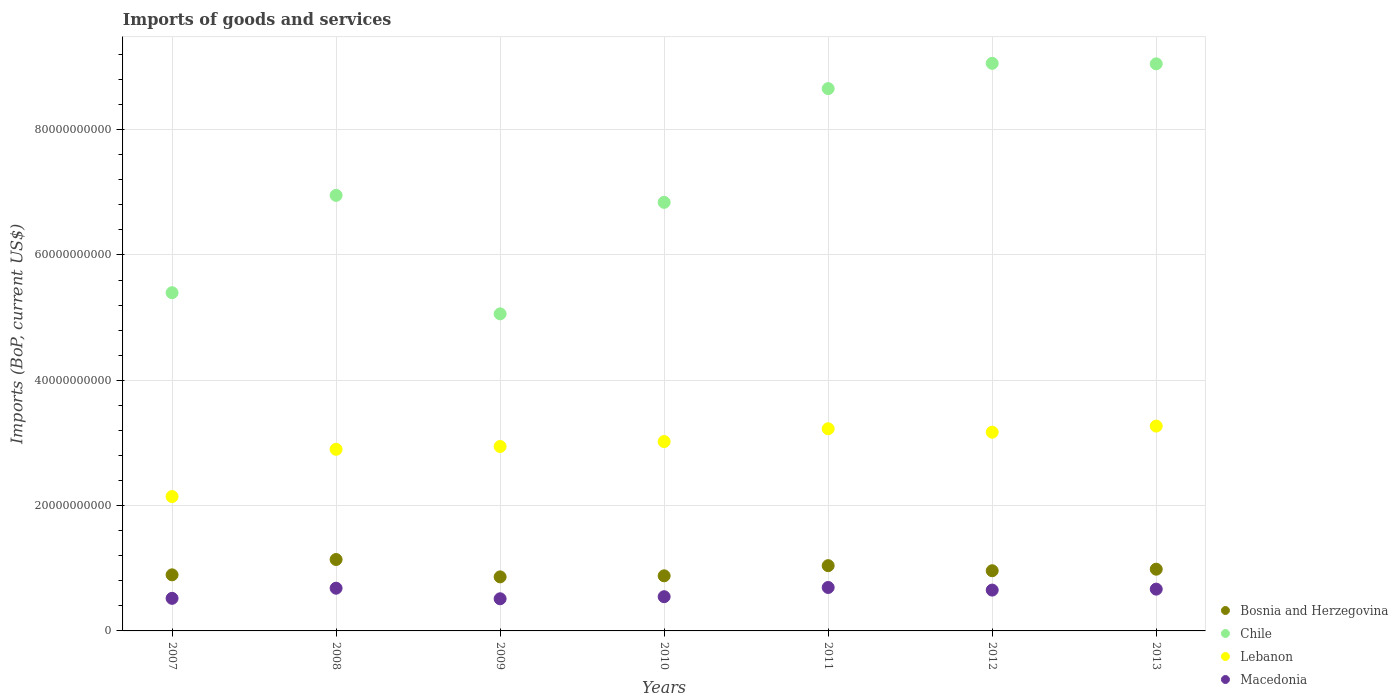What is the amount spent on imports in Chile in 2012?
Your response must be concise. 9.06e+1. Across all years, what is the maximum amount spent on imports in Bosnia and Herzegovina?
Offer a very short reply. 1.14e+1. Across all years, what is the minimum amount spent on imports in Lebanon?
Make the answer very short. 2.14e+1. What is the total amount spent on imports in Bosnia and Herzegovina in the graph?
Offer a terse response. 6.76e+1. What is the difference between the amount spent on imports in Chile in 2011 and that in 2012?
Ensure brevity in your answer.  -4.03e+09. What is the difference between the amount spent on imports in Bosnia and Herzegovina in 2013 and the amount spent on imports in Macedonia in 2008?
Offer a very short reply. 3.03e+09. What is the average amount spent on imports in Chile per year?
Give a very brief answer. 7.29e+1. In the year 2010, what is the difference between the amount spent on imports in Chile and amount spent on imports in Bosnia and Herzegovina?
Make the answer very short. 5.96e+1. What is the ratio of the amount spent on imports in Macedonia in 2007 to that in 2012?
Your response must be concise. 0.8. Is the amount spent on imports in Bosnia and Herzegovina in 2008 less than that in 2013?
Provide a short and direct response. No. Is the difference between the amount spent on imports in Chile in 2008 and 2010 greater than the difference between the amount spent on imports in Bosnia and Herzegovina in 2008 and 2010?
Your answer should be very brief. No. What is the difference between the highest and the second highest amount spent on imports in Chile?
Your response must be concise. 7.72e+07. What is the difference between the highest and the lowest amount spent on imports in Bosnia and Herzegovina?
Your answer should be compact. 2.77e+09. Does the amount spent on imports in Bosnia and Herzegovina monotonically increase over the years?
Offer a very short reply. No. How many dotlines are there?
Provide a succinct answer. 4. How many years are there in the graph?
Offer a very short reply. 7. Are the values on the major ticks of Y-axis written in scientific E-notation?
Give a very brief answer. No. Does the graph contain grids?
Provide a short and direct response. Yes. What is the title of the graph?
Offer a terse response. Imports of goods and services. Does "Guam" appear as one of the legend labels in the graph?
Your answer should be compact. No. What is the label or title of the Y-axis?
Offer a very short reply. Imports (BoP, current US$). What is the Imports (BoP, current US$) in Bosnia and Herzegovina in 2007?
Your answer should be compact. 8.95e+09. What is the Imports (BoP, current US$) in Chile in 2007?
Your response must be concise. 5.40e+1. What is the Imports (BoP, current US$) in Lebanon in 2007?
Make the answer very short. 2.14e+1. What is the Imports (BoP, current US$) of Macedonia in 2007?
Ensure brevity in your answer.  5.20e+09. What is the Imports (BoP, current US$) in Bosnia and Herzegovina in 2008?
Offer a very short reply. 1.14e+1. What is the Imports (BoP, current US$) in Chile in 2008?
Make the answer very short. 6.95e+1. What is the Imports (BoP, current US$) in Lebanon in 2008?
Provide a short and direct response. 2.90e+1. What is the Imports (BoP, current US$) of Macedonia in 2008?
Give a very brief answer. 6.82e+09. What is the Imports (BoP, current US$) of Bosnia and Herzegovina in 2009?
Offer a terse response. 8.62e+09. What is the Imports (BoP, current US$) in Chile in 2009?
Provide a succinct answer. 5.06e+1. What is the Imports (BoP, current US$) of Lebanon in 2009?
Your answer should be compact. 2.94e+1. What is the Imports (BoP, current US$) in Macedonia in 2009?
Make the answer very short. 5.13e+09. What is the Imports (BoP, current US$) in Bosnia and Herzegovina in 2010?
Provide a succinct answer. 8.79e+09. What is the Imports (BoP, current US$) in Chile in 2010?
Your answer should be very brief. 6.84e+1. What is the Imports (BoP, current US$) of Lebanon in 2010?
Offer a terse response. 3.02e+1. What is the Imports (BoP, current US$) of Macedonia in 2010?
Provide a succinct answer. 5.46e+09. What is the Imports (BoP, current US$) in Bosnia and Herzegovina in 2011?
Offer a very short reply. 1.04e+1. What is the Imports (BoP, current US$) in Chile in 2011?
Offer a very short reply. 8.66e+1. What is the Imports (BoP, current US$) of Lebanon in 2011?
Your answer should be compact. 3.23e+1. What is the Imports (BoP, current US$) of Macedonia in 2011?
Provide a succinct answer. 6.93e+09. What is the Imports (BoP, current US$) of Bosnia and Herzegovina in 2012?
Make the answer very short. 9.60e+09. What is the Imports (BoP, current US$) in Chile in 2012?
Your response must be concise. 9.06e+1. What is the Imports (BoP, current US$) of Lebanon in 2012?
Your answer should be very brief. 3.17e+1. What is the Imports (BoP, current US$) in Macedonia in 2012?
Provide a short and direct response. 6.52e+09. What is the Imports (BoP, current US$) in Bosnia and Herzegovina in 2013?
Your response must be concise. 9.85e+09. What is the Imports (BoP, current US$) of Chile in 2013?
Your answer should be very brief. 9.05e+1. What is the Imports (BoP, current US$) in Lebanon in 2013?
Make the answer very short. 3.27e+1. What is the Imports (BoP, current US$) in Macedonia in 2013?
Make the answer very short. 6.67e+09. Across all years, what is the maximum Imports (BoP, current US$) in Bosnia and Herzegovina?
Provide a succinct answer. 1.14e+1. Across all years, what is the maximum Imports (BoP, current US$) of Chile?
Make the answer very short. 9.06e+1. Across all years, what is the maximum Imports (BoP, current US$) of Lebanon?
Offer a terse response. 3.27e+1. Across all years, what is the maximum Imports (BoP, current US$) of Macedonia?
Offer a terse response. 6.93e+09. Across all years, what is the minimum Imports (BoP, current US$) of Bosnia and Herzegovina?
Ensure brevity in your answer.  8.62e+09. Across all years, what is the minimum Imports (BoP, current US$) of Chile?
Provide a succinct answer. 5.06e+1. Across all years, what is the minimum Imports (BoP, current US$) of Lebanon?
Make the answer very short. 2.14e+1. Across all years, what is the minimum Imports (BoP, current US$) of Macedonia?
Ensure brevity in your answer.  5.13e+09. What is the total Imports (BoP, current US$) in Bosnia and Herzegovina in the graph?
Your response must be concise. 6.76e+1. What is the total Imports (BoP, current US$) of Chile in the graph?
Ensure brevity in your answer.  5.10e+11. What is the total Imports (BoP, current US$) in Lebanon in the graph?
Offer a very short reply. 2.07e+11. What is the total Imports (BoP, current US$) in Macedonia in the graph?
Offer a terse response. 4.27e+1. What is the difference between the Imports (BoP, current US$) in Bosnia and Herzegovina in 2007 and that in 2008?
Ensure brevity in your answer.  -2.45e+09. What is the difference between the Imports (BoP, current US$) of Chile in 2007 and that in 2008?
Your answer should be compact. -1.55e+1. What is the difference between the Imports (BoP, current US$) of Lebanon in 2007 and that in 2008?
Keep it short and to the point. -7.54e+09. What is the difference between the Imports (BoP, current US$) in Macedonia in 2007 and that in 2008?
Your answer should be compact. -1.62e+09. What is the difference between the Imports (BoP, current US$) in Bosnia and Herzegovina in 2007 and that in 2009?
Offer a terse response. 3.25e+08. What is the difference between the Imports (BoP, current US$) of Chile in 2007 and that in 2009?
Your answer should be compact. 3.37e+09. What is the difference between the Imports (BoP, current US$) in Lebanon in 2007 and that in 2009?
Give a very brief answer. -7.99e+09. What is the difference between the Imports (BoP, current US$) of Macedonia in 2007 and that in 2009?
Offer a very short reply. 6.79e+07. What is the difference between the Imports (BoP, current US$) in Bosnia and Herzegovina in 2007 and that in 2010?
Your response must be concise. 1.56e+08. What is the difference between the Imports (BoP, current US$) of Chile in 2007 and that in 2010?
Provide a short and direct response. -1.44e+1. What is the difference between the Imports (BoP, current US$) of Lebanon in 2007 and that in 2010?
Your answer should be compact. -8.78e+09. What is the difference between the Imports (BoP, current US$) of Macedonia in 2007 and that in 2010?
Offer a very short reply. -2.63e+08. What is the difference between the Imports (BoP, current US$) in Bosnia and Herzegovina in 2007 and that in 2011?
Offer a very short reply. -1.47e+09. What is the difference between the Imports (BoP, current US$) in Chile in 2007 and that in 2011?
Offer a very short reply. -3.26e+1. What is the difference between the Imports (BoP, current US$) in Lebanon in 2007 and that in 2011?
Your answer should be very brief. -1.08e+1. What is the difference between the Imports (BoP, current US$) in Macedonia in 2007 and that in 2011?
Your response must be concise. -1.73e+09. What is the difference between the Imports (BoP, current US$) in Bosnia and Herzegovina in 2007 and that in 2012?
Offer a terse response. -6.55e+08. What is the difference between the Imports (BoP, current US$) in Chile in 2007 and that in 2012?
Give a very brief answer. -3.66e+1. What is the difference between the Imports (BoP, current US$) of Lebanon in 2007 and that in 2012?
Provide a short and direct response. -1.03e+1. What is the difference between the Imports (BoP, current US$) of Macedonia in 2007 and that in 2012?
Give a very brief answer. -1.32e+09. What is the difference between the Imports (BoP, current US$) in Bosnia and Herzegovina in 2007 and that in 2013?
Your answer should be compact. -9.02e+08. What is the difference between the Imports (BoP, current US$) in Chile in 2007 and that in 2013?
Provide a short and direct response. -3.65e+1. What is the difference between the Imports (BoP, current US$) in Lebanon in 2007 and that in 2013?
Your answer should be very brief. -1.12e+1. What is the difference between the Imports (BoP, current US$) of Macedonia in 2007 and that in 2013?
Offer a very short reply. -1.47e+09. What is the difference between the Imports (BoP, current US$) of Bosnia and Herzegovina in 2008 and that in 2009?
Provide a short and direct response. 2.77e+09. What is the difference between the Imports (BoP, current US$) of Chile in 2008 and that in 2009?
Your answer should be compact. 1.89e+1. What is the difference between the Imports (BoP, current US$) in Lebanon in 2008 and that in 2009?
Make the answer very short. -4.48e+08. What is the difference between the Imports (BoP, current US$) of Macedonia in 2008 and that in 2009?
Offer a terse response. 1.69e+09. What is the difference between the Imports (BoP, current US$) in Bosnia and Herzegovina in 2008 and that in 2010?
Offer a terse response. 2.60e+09. What is the difference between the Imports (BoP, current US$) in Chile in 2008 and that in 2010?
Give a very brief answer. 1.12e+09. What is the difference between the Imports (BoP, current US$) of Lebanon in 2008 and that in 2010?
Offer a very short reply. -1.23e+09. What is the difference between the Imports (BoP, current US$) of Macedonia in 2008 and that in 2010?
Give a very brief answer. 1.36e+09. What is the difference between the Imports (BoP, current US$) in Bosnia and Herzegovina in 2008 and that in 2011?
Offer a very short reply. 9.82e+08. What is the difference between the Imports (BoP, current US$) in Chile in 2008 and that in 2011?
Provide a succinct answer. -1.70e+1. What is the difference between the Imports (BoP, current US$) in Lebanon in 2008 and that in 2011?
Keep it short and to the point. -3.28e+09. What is the difference between the Imports (BoP, current US$) of Macedonia in 2008 and that in 2011?
Your answer should be compact. -1.15e+08. What is the difference between the Imports (BoP, current US$) of Bosnia and Herzegovina in 2008 and that in 2012?
Ensure brevity in your answer.  1.79e+09. What is the difference between the Imports (BoP, current US$) of Chile in 2008 and that in 2012?
Your response must be concise. -2.11e+1. What is the difference between the Imports (BoP, current US$) of Lebanon in 2008 and that in 2012?
Your response must be concise. -2.73e+09. What is the difference between the Imports (BoP, current US$) in Macedonia in 2008 and that in 2012?
Offer a terse response. 3.02e+08. What is the difference between the Imports (BoP, current US$) in Bosnia and Herzegovina in 2008 and that in 2013?
Provide a succinct answer. 1.55e+09. What is the difference between the Imports (BoP, current US$) of Chile in 2008 and that in 2013?
Provide a succinct answer. -2.10e+1. What is the difference between the Imports (BoP, current US$) in Lebanon in 2008 and that in 2013?
Provide a succinct answer. -3.70e+09. What is the difference between the Imports (BoP, current US$) of Macedonia in 2008 and that in 2013?
Your answer should be compact. 1.50e+08. What is the difference between the Imports (BoP, current US$) of Bosnia and Herzegovina in 2009 and that in 2010?
Offer a very short reply. -1.69e+08. What is the difference between the Imports (BoP, current US$) in Chile in 2009 and that in 2010?
Your answer should be compact. -1.78e+1. What is the difference between the Imports (BoP, current US$) in Lebanon in 2009 and that in 2010?
Give a very brief answer. -7.85e+08. What is the difference between the Imports (BoP, current US$) of Macedonia in 2009 and that in 2010?
Give a very brief answer. -3.31e+08. What is the difference between the Imports (BoP, current US$) in Bosnia and Herzegovina in 2009 and that in 2011?
Offer a very short reply. -1.79e+09. What is the difference between the Imports (BoP, current US$) of Chile in 2009 and that in 2011?
Provide a succinct answer. -3.60e+1. What is the difference between the Imports (BoP, current US$) in Lebanon in 2009 and that in 2011?
Give a very brief answer. -2.83e+09. What is the difference between the Imports (BoP, current US$) in Macedonia in 2009 and that in 2011?
Your response must be concise. -1.80e+09. What is the difference between the Imports (BoP, current US$) of Bosnia and Herzegovina in 2009 and that in 2012?
Ensure brevity in your answer.  -9.80e+08. What is the difference between the Imports (BoP, current US$) of Chile in 2009 and that in 2012?
Give a very brief answer. -4.00e+1. What is the difference between the Imports (BoP, current US$) in Lebanon in 2009 and that in 2012?
Offer a very short reply. -2.28e+09. What is the difference between the Imports (BoP, current US$) in Macedonia in 2009 and that in 2012?
Give a very brief answer. -1.39e+09. What is the difference between the Imports (BoP, current US$) of Bosnia and Herzegovina in 2009 and that in 2013?
Your response must be concise. -1.23e+09. What is the difference between the Imports (BoP, current US$) in Chile in 2009 and that in 2013?
Make the answer very short. -3.99e+1. What is the difference between the Imports (BoP, current US$) of Lebanon in 2009 and that in 2013?
Provide a short and direct response. -3.26e+09. What is the difference between the Imports (BoP, current US$) in Macedonia in 2009 and that in 2013?
Provide a succinct answer. -1.54e+09. What is the difference between the Imports (BoP, current US$) in Bosnia and Herzegovina in 2010 and that in 2011?
Ensure brevity in your answer.  -1.62e+09. What is the difference between the Imports (BoP, current US$) of Chile in 2010 and that in 2011?
Ensure brevity in your answer.  -1.82e+1. What is the difference between the Imports (BoP, current US$) in Lebanon in 2010 and that in 2011?
Provide a succinct answer. -2.05e+09. What is the difference between the Imports (BoP, current US$) in Macedonia in 2010 and that in 2011?
Provide a succinct answer. -1.47e+09. What is the difference between the Imports (BoP, current US$) in Bosnia and Herzegovina in 2010 and that in 2012?
Your response must be concise. -8.11e+08. What is the difference between the Imports (BoP, current US$) of Chile in 2010 and that in 2012?
Ensure brevity in your answer.  -2.22e+1. What is the difference between the Imports (BoP, current US$) in Lebanon in 2010 and that in 2012?
Your response must be concise. -1.50e+09. What is the difference between the Imports (BoP, current US$) of Macedonia in 2010 and that in 2012?
Your answer should be very brief. -1.05e+09. What is the difference between the Imports (BoP, current US$) in Bosnia and Herzegovina in 2010 and that in 2013?
Your answer should be compact. -1.06e+09. What is the difference between the Imports (BoP, current US$) in Chile in 2010 and that in 2013?
Provide a short and direct response. -2.21e+1. What is the difference between the Imports (BoP, current US$) of Lebanon in 2010 and that in 2013?
Make the answer very short. -2.47e+09. What is the difference between the Imports (BoP, current US$) in Macedonia in 2010 and that in 2013?
Your response must be concise. -1.21e+09. What is the difference between the Imports (BoP, current US$) of Bosnia and Herzegovina in 2011 and that in 2012?
Your answer should be very brief. 8.11e+08. What is the difference between the Imports (BoP, current US$) of Chile in 2011 and that in 2012?
Provide a succinct answer. -4.03e+09. What is the difference between the Imports (BoP, current US$) in Lebanon in 2011 and that in 2012?
Your response must be concise. 5.51e+08. What is the difference between the Imports (BoP, current US$) in Macedonia in 2011 and that in 2012?
Your response must be concise. 4.17e+08. What is the difference between the Imports (BoP, current US$) of Bosnia and Herzegovina in 2011 and that in 2013?
Your answer should be compact. 5.64e+08. What is the difference between the Imports (BoP, current US$) in Chile in 2011 and that in 2013?
Your answer should be very brief. -3.95e+09. What is the difference between the Imports (BoP, current US$) of Lebanon in 2011 and that in 2013?
Give a very brief answer. -4.26e+08. What is the difference between the Imports (BoP, current US$) in Macedonia in 2011 and that in 2013?
Give a very brief answer. 2.65e+08. What is the difference between the Imports (BoP, current US$) of Bosnia and Herzegovina in 2012 and that in 2013?
Provide a succinct answer. -2.47e+08. What is the difference between the Imports (BoP, current US$) of Chile in 2012 and that in 2013?
Keep it short and to the point. 7.72e+07. What is the difference between the Imports (BoP, current US$) of Lebanon in 2012 and that in 2013?
Give a very brief answer. -9.77e+08. What is the difference between the Imports (BoP, current US$) of Macedonia in 2012 and that in 2013?
Provide a short and direct response. -1.52e+08. What is the difference between the Imports (BoP, current US$) in Bosnia and Herzegovina in 2007 and the Imports (BoP, current US$) in Chile in 2008?
Provide a short and direct response. -6.06e+1. What is the difference between the Imports (BoP, current US$) of Bosnia and Herzegovina in 2007 and the Imports (BoP, current US$) of Lebanon in 2008?
Provide a succinct answer. -2.00e+1. What is the difference between the Imports (BoP, current US$) of Bosnia and Herzegovina in 2007 and the Imports (BoP, current US$) of Macedonia in 2008?
Keep it short and to the point. 2.13e+09. What is the difference between the Imports (BoP, current US$) in Chile in 2007 and the Imports (BoP, current US$) in Lebanon in 2008?
Ensure brevity in your answer.  2.50e+1. What is the difference between the Imports (BoP, current US$) of Chile in 2007 and the Imports (BoP, current US$) of Macedonia in 2008?
Provide a short and direct response. 4.72e+1. What is the difference between the Imports (BoP, current US$) of Lebanon in 2007 and the Imports (BoP, current US$) of Macedonia in 2008?
Give a very brief answer. 1.46e+1. What is the difference between the Imports (BoP, current US$) of Bosnia and Herzegovina in 2007 and the Imports (BoP, current US$) of Chile in 2009?
Provide a short and direct response. -4.17e+1. What is the difference between the Imports (BoP, current US$) in Bosnia and Herzegovina in 2007 and the Imports (BoP, current US$) in Lebanon in 2009?
Keep it short and to the point. -2.05e+1. What is the difference between the Imports (BoP, current US$) of Bosnia and Herzegovina in 2007 and the Imports (BoP, current US$) of Macedonia in 2009?
Give a very brief answer. 3.82e+09. What is the difference between the Imports (BoP, current US$) of Chile in 2007 and the Imports (BoP, current US$) of Lebanon in 2009?
Provide a succinct answer. 2.45e+1. What is the difference between the Imports (BoP, current US$) of Chile in 2007 and the Imports (BoP, current US$) of Macedonia in 2009?
Provide a succinct answer. 4.88e+1. What is the difference between the Imports (BoP, current US$) in Lebanon in 2007 and the Imports (BoP, current US$) in Macedonia in 2009?
Your answer should be compact. 1.63e+1. What is the difference between the Imports (BoP, current US$) of Bosnia and Herzegovina in 2007 and the Imports (BoP, current US$) of Chile in 2010?
Your answer should be compact. -5.95e+1. What is the difference between the Imports (BoP, current US$) of Bosnia and Herzegovina in 2007 and the Imports (BoP, current US$) of Lebanon in 2010?
Make the answer very short. -2.13e+1. What is the difference between the Imports (BoP, current US$) of Bosnia and Herzegovina in 2007 and the Imports (BoP, current US$) of Macedonia in 2010?
Make the answer very short. 3.49e+09. What is the difference between the Imports (BoP, current US$) in Chile in 2007 and the Imports (BoP, current US$) in Lebanon in 2010?
Your response must be concise. 2.38e+1. What is the difference between the Imports (BoP, current US$) of Chile in 2007 and the Imports (BoP, current US$) of Macedonia in 2010?
Your answer should be very brief. 4.85e+1. What is the difference between the Imports (BoP, current US$) in Lebanon in 2007 and the Imports (BoP, current US$) in Macedonia in 2010?
Provide a succinct answer. 1.60e+1. What is the difference between the Imports (BoP, current US$) in Bosnia and Herzegovina in 2007 and the Imports (BoP, current US$) in Chile in 2011?
Keep it short and to the point. -7.76e+1. What is the difference between the Imports (BoP, current US$) in Bosnia and Herzegovina in 2007 and the Imports (BoP, current US$) in Lebanon in 2011?
Ensure brevity in your answer.  -2.33e+1. What is the difference between the Imports (BoP, current US$) in Bosnia and Herzegovina in 2007 and the Imports (BoP, current US$) in Macedonia in 2011?
Offer a terse response. 2.02e+09. What is the difference between the Imports (BoP, current US$) in Chile in 2007 and the Imports (BoP, current US$) in Lebanon in 2011?
Offer a terse response. 2.17e+1. What is the difference between the Imports (BoP, current US$) in Chile in 2007 and the Imports (BoP, current US$) in Macedonia in 2011?
Your answer should be compact. 4.70e+1. What is the difference between the Imports (BoP, current US$) of Lebanon in 2007 and the Imports (BoP, current US$) of Macedonia in 2011?
Offer a terse response. 1.45e+1. What is the difference between the Imports (BoP, current US$) of Bosnia and Herzegovina in 2007 and the Imports (BoP, current US$) of Chile in 2012?
Make the answer very short. -8.16e+1. What is the difference between the Imports (BoP, current US$) in Bosnia and Herzegovina in 2007 and the Imports (BoP, current US$) in Lebanon in 2012?
Your response must be concise. -2.28e+1. What is the difference between the Imports (BoP, current US$) of Bosnia and Herzegovina in 2007 and the Imports (BoP, current US$) of Macedonia in 2012?
Your answer should be compact. 2.43e+09. What is the difference between the Imports (BoP, current US$) in Chile in 2007 and the Imports (BoP, current US$) in Lebanon in 2012?
Provide a short and direct response. 2.23e+1. What is the difference between the Imports (BoP, current US$) in Chile in 2007 and the Imports (BoP, current US$) in Macedonia in 2012?
Offer a very short reply. 4.75e+1. What is the difference between the Imports (BoP, current US$) of Lebanon in 2007 and the Imports (BoP, current US$) of Macedonia in 2012?
Provide a short and direct response. 1.49e+1. What is the difference between the Imports (BoP, current US$) of Bosnia and Herzegovina in 2007 and the Imports (BoP, current US$) of Chile in 2013?
Offer a very short reply. -8.16e+1. What is the difference between the Imports (BoP, current US$) in Bosnia and Herzegovina in 2007 and the Imports (BoP, current US$) in Lebanon in 2013?
Give a very brief answer. -2.37e+1. What is the difference between the Imports (BoP, current US$) of Bosnia and Herzegovina in 2007 and the Imports (BoP, current US$) of Macedonia in 2013?
Your answer should be very brief. 2.28e+09. What is the difference between the Imports (BoP, current US$) of Chile in 2007 and the Imports (BoP, current US$) of Lebanon in 2013?
Offer a terse response. 2.13e+1. What is the difference between the Imports (BoP, current US$) of Chile in 2007 and the Imports (BoP, current US$) of Macedonia in 2013?
Keep it short and to the point. 4.73e+1. What is the difference between the Imports (BoP, current US$) of Lebanon in 2007 and the Imports (BoP, current US$) of Macedonia in 2013?
Keep it short and to the point. 1.48e+1. What is the difference between the Imports (BoP, current US$) in Bosnia and Herzegovina in 2008 and the Imports (BoP, current US$) in Chile in 2009?
Ensure brevity in your answer.  -3.92e+1. What is the difference between the Imports (BoP, current US$) of Bosnia and Herzegovina in 2008 and the Imports (BoP, current US$) of Lebanon in 2009?
Provide a short and direct response. -1.80e+1. What is the difference between the Imports (BoP, current US$) in Bosnia and Herzegovina in 2008 and the Imports (BoP, current US$) in Macedonia in 2009?
Give a very brief answer. 6.27e+09. What is the difference between the Imports (BoP, current US$) of Chile in 2008 and the Imports (BoP, current US$) of Lebanon in 2009?
Ensure brevity in your answer.  4.01e+1. What is the difference between the Imports (BoP, current US$) of Chile in 2008 and the Imports (BoP, current US$) of Macedonia in 2009?
Your answer should be very brief. 6.44e+1. What is the difference between the Imports (BoP, current US$) of Lebanon in 2008 and the Imports (BoP, current US$) of Macedonia in 2009?
Offer a terse response. 2.39e+1. What is the difference between the Imports (BoP, current US$) of Bosnia and Herzegovina in 2008 and the Imports (BoP, current US$) of Chile in 2010?
Ensure brevity in your answer.  -5.70e+1. What is the difference between the Imports (BoP, current US$) in Bosnia and Herzegovina in 2008 and the Imports (BoP, current US$) in Lebanon in 2010?
Keep it short and to the point. -1.88e+1. What is the difference between the Imports (BoP, current US$) in Bosnia and Herzegovina in 2008 and the Imports (BoP, current US$) in Macedonia in 2010?
Provide a short and direct response. 5.93e+09. What is the difference between the Imports (BoP, current US$) of Chile in 2008 and the Imports (BoP, current US$) of Lebanon in 2010?
Keep it short and to the point. 3.93e+1. What is the difference between the Imports (BoP, current US$) of Chile in 2008 and the Imports (BoP, current US$) of Macedonia in 2010?
Offer a very short reply. 6.41e+1. What is the difference between the Imports (BoP, current US$) in Lebanon in 2008 and the Imports (BoP, current US$) in Macedonia in 2010?
Keep it short and to the point. 2.35e+1. What is the difference between the Imports (BoP, current US$) of Bosnia and Herzegovina in 2008 and the Imports (BoP, current US$) of Chile in 2011?
Give a very brief answer. -7.52e+1. What is the difference between the Imports (BoP, current US$) of Bosnia and Herzegovina in 2008 and the Imports (BoP, current US$) of Lebanon in 2011?
Your answer should be very brief. -2.09e+1. What is the difference between the Imports (BoP, current US$) of Bosnia and Herzegovina in 2008 and the Imports (BoP, current US$) of Macedonia in 2011?
Provide a short and direct response. 4.46e+09. What is the difference between the Imports (BoP, current US$) in Chile in 2008 and the Imports (BoP, current US$) in Lebanon in 2011?
Your answer should be compact. 3.72e+1. What is the difference between the Imports (BoP, current US$) of Chile in 2008 and the Imports (BoP, current US$) of Macedonia in 2011?
Your response must be concise. 6.26e+1. What is the difference between the Imports (BoP, current US$) of Lebanon in 2008 and the Imports (BoP, current US$) of Macedonia in 2011?
Provide a succinct answer. 2.21e+1. What is the difference between the Imports (BoP, current US$) of Bosnia and Herzegovina in 2008 and the Imports (BoP, current US$) of Chile in 2012?
Give a very brief answer. -7.92e+1. What is the difference between the Imports (BoP, current US$) of Bosnia and Herzegovina in 2008 and the Imports (BoP, current US$) of Lebanon in 2012?
Your answer should be very brief. -2.03e+1. What is the difference between the Imports (BoP, current US$) in Bosnia and Herzegovina in 2008 and the Imports (BoP, current US$) in Macedonia in 2012?
Make the answer very short. 4.88e+09. What is the difference between the Imports (BoP, current US$) in Chile in 2008 and the Imports (BoP, current US$) in Lebanon in 2012?
Keep it short and to the point. 3.78e+1. What is the difference between the Imports (BoP, current US$) of Chile in 2008 and the Imports (BoP, current US$) of Macedonia in 2012?
Provide a succinct answer. 6.30e+1. What is the difference between the Imports (BoP, current US$) in Lebanon in 2008 and the Imports (BoP, current US$) in Macedonia in 2012?
Your response must be concise. 2.25e+1. What is the difference between the Imports (BoP, current US$) of Bosnia and Herzegovina in 2008 and the Imports (BoP, current US$) of Chile in 2013?
Your answer should be very brief. -7.91e+1. What is the difference between the Imports (BoP, current US$) in Bosnia and Herzegovina in 2008 and the Imports (BoP, current US$) in Lebanon in 2013?
Keep it short and to the point. -2.13e+1. What is the difference between the Imports (BoP, current US$) of Bosnia and Herzegovina in 2008 and the Imports (BoP, current US$) of Macedonia in 2013?
Keep it short and to the point. 4.73e+09. What is the difference between the Imports (BoP, current US$) in Chile in 2008 and the Imports (BoP, current US$) in Lebanon in 2013?
Make the answer very short. 3.68e+1. What is the difference between the Imports (BoP, current US$) of Chile in 2008 and the Imports (BoP, current US$) of Macedonia in 2013?
Your response must be concise. 6.28e+1. What is the difference between the Imports (BoP, current US$) in Lebanon in 2008 and the Imports (BoP, current US$) in Macedonia in 2013?
Your response must be concise. 2.23e+1. What is the difference between the Imports (BoP, current US$) in Bosnia and Herzegovina in 2009 and the Imports (BoP, current US$) in Chile in 2010?
Your answer should be very brief. -5.98e+1. What is the difference between the Imports (BoP, current US$) of Bosnia and Herzegovina in 2009 and the Imports (BoP, current US$) of Lebanon in 2010?
Provide a short and direct response. -2.16e+1. What is the difference between the Imports (BoP, current US$) in Bosnia and Herzegovina in 2009 and the Imports (BoP, current US$) in Macedonia in 2010?
Your response must be concise. 3.16e+09. What is the difference between the Imports (BoP, current US$) of Chile in 2009 and the Imports (BoP, current US$) of Lebanon in 2010?
Your response must be concise. 2.04e+1. What is the difference between the Imports (BoP, current US$) in Chile in 2009 and the Imports (BoP, current US$) in Macedonia in 2010?
Offer a terse response. 4.51e+1. What is the difference between the Imports (BoP, current US$) in Lebanon in 2009 and the Imports (BoP, current US$) in Macedonia in 2010?
Your answer should be very brief. 2.40e+1. What is the difference between the Imports (BoP, current US$) of Bosnia and Herzegovina in 2009 and the Imports (BoP, current US$) of Chile in 2011?
Offer a terse response. -7.79e+1. What is the difference between the Imports (BoP, current US$) in Bosnia and Herzegovina in 2009 and the Imports (BoP, current US$) in Lebanon in 2011?
Your response must be concise. -2.36e+1. What is the difference between the Imports (BoP, current US$) of Bosnia and Herzegovina in 2009 and the Imports (BoP, current US$) of Macedonia in 2011?
Provide a succinct answer. 1.69e+09. What is the difference between the Imports (BoP, current US$) in Chile in 2009 and the Imports (BoP, current US$) in Lebanon in 2011?
Give a very brief answer. 1.83e+1. What is the difference between the Imports (BoP, current US$) in Chile in 2009 and the Imports (BoP, current US$) in Macedonia in 2011?
Ensure brevity in your answer.  4.37e+1. What is the difference between the Imports (BoP, current US$) of Lebanon in 2009 and the Imports (BoP, current US$) of Macedonia in 2011?
Your response must be concise. 2.25e+1. What is the difference between the Imports (BoP, current US$) in Bosnia and Herzegovina in 2009 and the Imports (BoP, current US$) in Chile in 2012?
Your answer should be very brief. -8.20e+1. What is the difference between the Imports (BoP, current US$) in Bosnia and Herzegovina in 2009 and the Imports (BoP, current US$) in Lebanon in 2012?
Your answer should be compact. -2.31e+1. What is the difference between the Imports (BoP, current US$) in Bosnia and Herzegovina in 2009 and the Imports (BoP, current US$) in Macedonia in 2012?
Your response must be concise. 2.11e+09. What is the difference between the Imports (BoP, current US$) of Chile in 2009 and the Imports (BoP, current US$) of Lebanon in 2012?
Give a very brief answer. 1.89e+1. What is the difference between the Imports (BoP, current US$) in Chile in 2009 and the Imports (BoP, current US$) in Macedonia in 2012?
Your answer should be very brief. 4.41e+1. What is the difference between the Imports (BoP, current US$) in Lebanon in 2009 and the Imports (BoP, current US$) in Macedonia in 2012?
Your answer should be compact. 2.29e+1. What is the difference between the Imports (BoP, current US$) in Bosnia and Herzegovina in 2009 and the Imports (BoP, current US$) in Chile in 2013?
Your response must be concise. -8.19e+1. What is the difference between the Imports (BoP, current US$) of Bosnia and Herzegovina in 2009 and the Imports (BoP, current US$) of Lebanon in 2013?
Your answer should be very brief. -2.41e+1. What is the difference between the Imports (BoP, current US$) of Bosnia and Herzegovina in 2009 and the Imports (BoP, current US$) of Macedonia in 2013?
Your response must be concise. 1.96e+09. What is the difference between the Imports (BoP, current US$) of Chile in 2009 and the Imports (BoP, current US$) of Lebanon in 2013?
Offer a terse response. 1.79e+1. What is the difference between the Imports (BoP, current US$) in Chile in 2009 and the Imports (BoP, current US$) in Macedonia in 2013?
Your answer should be very brief. 4.39e+1. What is the difference between the Imports (BoP, current US$) of Lebanon in 2009 and the Imports (BoP, current US$) of Macedonia in 2013?
Keep it short and to the point. 2.28e+1. What is the difference between the Imports (BoP, current US$) in Bosnia and Herzegovina in 2010 and the Imports (BoP, current US$) in Chile in 2011?
Your answer should be compact. -7.78e+1. What is the difference between the Imports (BoP, current US$) in Bosnia and Herzegovina in 2010 and the Imports (BoP, current US$) in Lebanon in 2011?
Keep it short and to the point. -2.35e+1. What is the difference between the Imports (BoP, current US$) of Bosnia and Herzegovina in 2010 and the Imports (BoP, current US$) of Macedonia in 2011?
Keep it short and to the point. 1.86e+09. What is the difference between the Imports (BoP, current US$) in Chile in 2010 and the Imports (BoP, current US$) in Lebanon in 2011?
Make the answer very short. 3.61e+1. What is the difference between the Imports (BoP, current US$) of Chile in 2010 and the Imports (BoP, current US$) of Macedonia in 2011?
Your answer should be compact. 6.15e+1. What is the difference between the Imports (BoP, current US$) in Lebanon in 2010 and the Imports (BoP, current US$) in Macedonia in 2011?
Your response must be concise. 2.33e+1. What is the difference between the Imports (BoP, current US$) of Bosnia and Herzegovina in 2010 and the Imports (BoP, current US$) of Chile in 2012?
Make the answer very short. -8.18e+1. What is the difference between the Imports (BoP, current US$) in Bosnia and Herzegovina in 2010 and the Imports (BoP, current US$) in Lebanon in 2012?
Your answer should be very brief. -2.29e+1. What is the difference between the Imports (BoP, current US$) in Bosnia and Herzegovina in 2010 and the Imports (BoP, current US$) in Macedonia in 2012?
Provide a succinct answer. 2.28e+09. What is the difference between the Imports (BoP, current US$) of Chile in 2010 and the Imports (BoP, current US$) of Lebanon in 2012?
Your answer should be very brief. 3.67e+1. What is the difference between the Imports (BoP, current US$) of Chile in 2010 and the Imports (BoP, current US$) of Macedonia in 2012?
Your answer should be very brief. 6.19e+1. What is the difference between the Imports (BoP, current US$) in Lebanon in 2010 and the Imports (BoP, current US$) in Macedonia in 2012?
Provide a short and direct response. 2.37e+1. What is the difference between the Imports (BoP, current US$) of Bosnia and Herzegovina in 2010 and the Imports (BoP, current US$) of Chile in 2013?
Your response must be concise. -8.17e+1. What is the difference between the Imports (BoP, current US$) in Bosnia and Herzegovina in 2010 and the Imports (BoP, current US$) in Lebanon in 2013?
Your response must be concise. -2.39e+1. What is the difference between the Imports (BoP, current US$) of Bosnia and Herzegovina in 2010 and the Imports (BoP, current US$) of Macedonia in 2013?
Keep it short and to the point. 2.12e+09. What is the difference between the Imports (BoP, current US$) of Chile in 2010 and the Imports (BoP, current US$) of Lebanon in 2013?
Your answer should be compact. 3.57e+1. What is the difference between the Imports (BoP, current US$) in Chile in 2010 and the Imports (BoP, current US$) in Macedonia in 2013?
Your answer should be compact. 6.17e+1. What is the difference between the Imports (BoP, current US$) of Lebanon in 2010 and the Imports (BoP, current US$) of Macedonia in 2013?
Make the answer very short. 2.36e+1. What is the difference between the Imports (BoP, current US$) in Bosnia and Herzegovina in 2011 and the Imports (BoP, current US$) in Chile in 2012?
Your answer should be very brief. -8.02e+1. What is the difference between the Imports (BoP, current US$) of Bosnia and Herzegovina in 2011 and the Imports (BoP, current US$) of Lebanon in 2012?
Provide a short and direct response. -2.13e+1. What is the difference between the Imports (BoP, current US$) in Bosnia and Herzegovina in 2011 and the Imports (BoP, current US$) in Macedonia in 2012?
Your answer should be very brief. 3.90e+09. What is the difference between the Imports (BoP, current US$) in Chile in 2011 and the Imports (BoP, current US$) in Lebanon in 2012?
Offer a very short reply. 5.48e+1. What is the difference between the Imports (BoP, current US$) of Chile in 2011 and the Imports (BoP, current US$) of Macedonia in 2012?
Offer a terse response. 8.00e+1. What is the difference between the Imports (BoP, current US$) in Lebanon in 2011 and the Imports (BoP, current US$) in Macedonia in 2012?
Provide a succinct answer. 2.57e+1. What is the difference between the Imports (BoP, current US$) in Bosnia and Herzegovina in 2011 and the Imports (BoP, current US$) in Chile in 2013?
Your answer should be very brief. -8.01e+1. What is the difference between the Imports (BoP, current US$) in Bosnia and Herzegovina in 2011 and the Imports (BoP, current US$) in Lebanon in 2013?
Give a very brief answer. -2.23e+1. What is the difference between the Imports (BoP, current US$) of Bosnia and Herzegovina in 2011 and the Imports (BoP, current US$) of Macedonia in 2013?
Keep it short and to the point. 3.75e+09. What is the difference between the Imports (BoP, current US$) of Chile in 2011 and the Imports (BoP, current US$) of Lebanon in 2013?
Provide a short and direct response. 5.39e+1. What is the difference between the Imports (BoP, current US$) of Chile in 2011 and the Imports (BoP, current US$) of Macedonia in 2013?
Offer a terse response. 7.99e+1. What is the difference between the Imports (BoP, current US$) in Lebanon in 2011 and the Imports (BoP, current US$) in Macedonia in 2013?
Keep it short and to the point. 2.56e+1. What is the difference between the Imports (BoP, current US$) in Bosnia and Herzegovina in 2012 and the Imports (BoP, current US$) in Chile in 2013?
Your answer should be very brief. -8.09e+1. What is the difference between the Imports (BoP, current US$) in Bosnia and Herzegovina in 2012 and the Imports (BoP, current US$) in Lebanon in 2013?
Give a very brief answer. -2.31e+1. What is the difference between the Imports (BoP, current US$) in Bosnia and Herzegovina in 2012 and the Imports (BoP, current US$) in Macedonia in 2013?
Give a very brief answer. 2.94e+09. What is the difference between the Imports (BoP, current US$) of Chile in 2012 and the Imports (BoP, current US$) of Lebanon in 2013?
Provide a short and direct response. 5.79e+1. What is the difference between the Imports (BoP, current US$) in Chile in 2012 and the Imports (BoP, current US$) in Macedonia in 2013?
Offer a terse response. 8.39e+1. What is the difference between the Imports (BoP, current US$) in Lebanon in 2012 and the Imports (BoP, current US$) in Macedonia in 2013?
Offer a very short reply. 2.50e+1. What is the average Imports (BoP, current US$) in Bosnia and Herzegovina per year?
Give a very brief answer. 9.66e+09. What is the average Imports (BoP, current US$) in Chile per year?
Keep it short and to the point. 7.29e+1. What is the average Imports (BoP, current US$) in Lebanon per year?
Your answer should be very brief. 2.95e+1. What is the average Imports (BoP, current US$) in Macedonia per year?
Your response must be concise. 6.11e+09. In the year 2007, what is the difference between the Imports (BoP, current US$) in Bosnia and Herzegovina and Imports (BoP, current US$) in Chile?
Your answer should be compact. -4.50e+1. In the year 2007, what is the difference between the Imports (BoP, current US$) in Bosnia and Herzegovina and Imports (BoP, current US$) in Lebanon?
Provide a short and direct response. -1.25e+1. In the year 2007, what is the difference between the Imports (BoP, current US$) of Bosnia and Herzegovina and Imports (BoP, current US$) of Macedonia?
Your answer should be very brief. 3.75e+09. In the year 2007, what is the difference between the Imports (BoP, current US$) in Chile and Imports (BoP, current US$) in Lebanon?
Your answer should be very brief. 3.25e+1. In the year 2007, what is the difference between the Imports (BoP, current US$) of Chile and Imports (BoP, current US$) of Macedonia?
Your answer should be compact. 4.88e+1. In the year 2007, what is the difference between the Imports (BoP, current US$) of Lebanon and Imports (BoP, current US$) of Macedonia?
Keep it short and to the point. 1.62e+1. In the year 2008, what is the difference between the Imports (BoP, current US$) in Bosnia and Herzegovina and Imports (BoP, current US$) in Chile?
Your answer should be very brief. -5.81e+1. In the year 2008, what is the difference between the Imports (BoP, current US$) in Bosnia and Herzegovina and Imports (BoP, current US$) in Lebanon?
Ensure brevity in your answer.  -1.76e+1. In the year 2008, what is the difference between the Imports (BoP, current US$) of Bosnia and Herzegovina and Imports (BoP, current US$) of Macedonia?
Make the answer very short. 4.58e+09. In the year 2008, what is the difference between the Imports (BoP, current US$) in Chile and Imports (BoP, current US$) in Lebanon?
Offer a terse response. 4.05e+1. In the year 2008, what is the difference between the Imports (BoP, current US$) in Chile and Imports (BoP, current US$) in Macedonia?
Provide a succinct answer. 6.27e+1. In the year 2008, what is the difference between the Imports (BoP, current US$) of Lebanon and Imports (BoP, current US$) of Macedonia?
Your response must be concise. 2.22e+1. In the year 2009, what is the difference between the Imports (BoP, current US$) in Bosnia and Herzegovina and Imports (BoP, current US$) in Chile?
Your answer should be compact. -4.20e+1. In the year 2009, what is the difference between the Imports (BoP, current US$) of Bosnia and Herzegovina and Imports (BoP, current US$) of Lebanon?
Provide a short and direct response. -2.08e+1. In the year 2009, what is the difference between the Imports (BoP, current US$) in Bosnia and Herzegovina and Imports (BoP, current US$) in Macedonia?
Provide a short and direct response. 3.49e+09. In the year 2009, what is the difference between the Imports (BoP, current US$) of Chile and Imports (BoP, current US$) of Lebanon?
Your answer should be compact. 2.12e+1. In the year 2009, what is the difference between the Imports (BoP, current US$) of Chile and Imports (BoP, current US$) of Macedonia?
Offer a very short reply. 4.55e+1. In the year 2009, what is the difference between the Imports (BoP, current US$) of Lebanon and Imports (BoP, current US$) of Macedonia?
Your answer should be very brief. 2.43e+1. In the year 2010, what is the difference between the Imports (BoP, current US$) in Bosnia and Herzegovina and Imports (BoP, current US$) in Chile?
Keep it short and to the point. -5.96e+1. In the year 2010, what is the difference between the Imports (BoP, current US$) of Bosnia and Herzegovina and Imports (BoP, current US$) of Lebanon?
Offer a very short reply. -2.14e+1. In the year 2010, what is the difference between the Imports (BoP, current US$) in Bosnia and Herzegovina and Imports (BoP, current US$) in Macedonia?
Provide a short and direct response. 3.33e+09. In the year 2010, what is the difference between the Imports (BoP, current US$) in Chile and Imports (BoP, current US$) in Lebanon?
Provide a short and direct response. 3.82e+1. In the year 2010, what is the difference between the Imports (BoP, current US$) in Chile and Imports (BoP, current US$) in Macedonia?
Your answer should be very brief. 6.29e+1. In the year 2010, what is the difference between the Imports (BoP, current US$) in Lebanon and Imports (BoP, current US$) in Macedonia?
Ensure brevity in your answer.  2.48e+1. In the year 2011, what is the difference between the Imports (BoP, current US$) of Bosnia and Herzegovina and Imports (BoP, current US$) of Chile?
Provide a short and direct response. -7.61e+1. In the year 2011, what is the difference between the Imports (BoP, current US$) in Bosnia and Herzegovina and Imports (BoP, current US$) in Lebanon?
Provide a succinct answer. -2.19e+1. In the year 2011, what is the difference between the Imports (BoP, current US$) of Bosnia and Herzegovina and Imports (BoP, current US$) of Macedonia?
Ensure brevity in your answer.  3.48e+09. In the year 2011, what is the difference between the Imports (BoP, current US$) in Chile and Imports (BoP, current US$) in Lebanon?
Offer a very short reply. 5.43e+1. In the year 2011, what is the difference between the Imports (BoP, current US$) of Chile and Imports (BoP, current US$) of Macedonia?
Your answer should be very brief. 7.96e+1. In the year 2011, what is the difference between the Imports (BoP, current US$) in Lebanon and Imports (BoP, current US$) in Macedonia?
Keep it short and to the point. 2.53e+1. In the year 2012, what is the difference between the Imports (BoP, current US$) of Bosnia and Herzegovina and Imports (BoP, current US$) of Chile?
Provide a short and direct response. -8.10e+1. In the year 2012, what is the difference between the Imports (BoP, current US$) in Bosnia and Herzegovina and Imports (BoP, current US$) in Lebanon?
Your answer should be compact. -2.21e+1. In the year 2012, what is the difference between the Imports (BoP, current US$) of Bosnia and Herzegovina and Imports (BoP, current US$) of Macedonia?
Offer a terse response. 3.09e+09. In the year 2012, what is the difference between the Imports (BoP, current US$) of Chile and Imports (BoP, current US$) of Lebanon?
Provide a succinct answer. 5.89e+1. In the year 2012, what is the difference between the Imports (BoP, current US$) of Chile and Imports (BoP, current US$) of Macedonia?
Provide a short and direct response. 8.41e+1. In the year 2012, what is the difference between the Imports (BoP, current US$) of Lebanon and Imports (BoP, current US$) of Macedonia?
Your response must be concise. 2.52e+1. In the year 2013, what is the difference between the Imports (BoP, current US$) of Bosnia and Herzegovina and Imports (BoP, current US$) of Chile?
Provide a short and direct response. -8.07e+1. In the year 2013, what is the difference between the Imports (BoP, current US$) of Bosnia and Herzegovina and Imports (BoP, current US$) of Lebanon?
Make the answer very short. -2.28e+1. In the year 2013, what is the difference between the Imports (BoP, current US$) of Bosnia and Herzegovina and Imports (BoP, current US$) of Macedonia?
Ensure brevity in your answer.  3.18e+09. In the year 2013, what is the difference between the Imports (BoP, current US$) of Chile and Imports (BoP, current US$) of Lebanon?
Your answer should be very brief. 5.78e+1. In the year 2013, what is the difference between the Imports (BoP, current US$) in Chile and Imports (BoP, current US$) in Macedonia?
Provide a succinct answer. 8.38e+1. In the year 2013, what is the difference between the Imports (BoP, current US$) of Lebanon and Imports (BoP, current US$) of Macedonia?
Keep it short and to the point. 2.60e+1. What is the ratio of the Imports (BoP, current US$) of Bosnia and Herzegovina in 2007 to that in 2008?
Provide a succinct answer. 0.79. What is the ratio of the Imports (BoP, current US$) in Chile in 2007 to that in 2008?
Your answer should be very brief. 0.78. What is the ratio of the Imports (BoP, current US$) in Lebanon in 2007 to that in 2008?
Your response must be concise. 0.74. What is the ratio of the Imports (BoP, current US$) of Macedonia in 2007 to that in 2008?
Give a very brief answer. 0.76. What is the ratio of the Imports (BoP, current US$) of Bosnia and Herzegovina in 2007 to that in 2009?
Keep it short and to the point. 1.04. What is the ratio of the Imports (BoP, current US$) of Chile in 2007 to that in 2009?
Provide a short and direct response. 1.07. What is the ratio of the Imports (BoP, current US$) in Lebanon in 2007 to that in 2009?
Offer a very short reply. 0.73. What is the ratio of the Imports (BoP, current US$) in Macedonia in 2007 to that in 2009?
Make the answer very short. 1.01. What is the ratio of the Imports (BoP, current US$) in Bosnia and Herzegovina in 2007 to that in 2010?
Offer a very short reply. 1.02. What is the ratio of the Imports (BoP, current US$) of Chile in 2007 to that in 2010?
Offer a terse response. 0.79. What is the ratio of the Imports (BoP, current US$) in Lebanon in 2007 to that in 2010?
Make the answer very short. 0.71. What is the ratio of the Imports (BoP, current US$) in Macedonia in 2007 to that in 2010?
Give a very brief answer. 0.95. What is the ratio of the Imports (BoP, current US$) of Bosnia and Herzegovina in 2007 to that in 2011?
Your response must be concise. 0.86. What is the ratio of the Imports (BoP, current US$) of Chile in 2007 to that in 2011?
Provide a short and direct response. 0.62. What is the ratio of the Imports (BoP, current US$) of Lebanon in 2007 to that in 2011?
Your answer should be very brief. 0.66. What is the ratio of the Imports (BoP, current US$) in Macedonia in 2007 to that in 2011?
Give a very brief answer. 0.75. What is the ratio of the Imports (BoP, current US$) of Bosnia and Herzegovina in 2007 to that in 2012?
Provide a succinct answer. 0.93. What is the ratio of the Imports (BoP, current US$) in Chile in 2007 to that in 2012?
Offer a terse response. 0.6. What is the ratio of the Imports (BoP, current US$) of Lebanon in 2007 to that in 2012?
Give a very brief answer. 0.68. What is the ratio of the Imports (BoP, current US$) in Macedonia in 2007 to that in 2012?
Offer a terse response. 0.8. What is the ratio of the Imports (BoP, current US$) of Bosnia and Herzegovina in 2007 to that in 2013?
Your response must be concise. 0.91. What is the ratio of the Imports (BoP, current US$) in Chile in 2007 to that in 2013?
Ensure brevity in your answer.  0.6. What is the ratio of the Imports (BoP, current US$) of Lebanon in 2007 to that in 2013?
Ensure brevity in your answer.  0.66. What is the ratio of the Imports (BoP, current US$) of Macedonia in 2007 to that in 2013?
Your answer should be very brief. 0.78. What is the ratio of the Imports (BoP, current US$) in Bosnia and Herzegovina in 2008 to that in 2009?
Provide a succinct answer. 1.32. What is the ratio of the Imports (BoP, current US$) in Chile in 2008 to that in 2009?
Offer a terse response. 1.37. What is the ratio of the Imports (BoP, current US$) of Lebanon in 2008 to that in 2009?
Keep it short and to the point. 0.98. What is the ratio of the Imports (BoP, current US$) in Macedonia in 2008 to that in 2009?
Your answer should be compact. 1.33. What is the ratio of the Imports (BoP, current US$) in Bosnia and Herzegovina in 2008 to that in 2010?
Keep it short and to the point. 1.3. What is the ratio of the Imports (BoP, current US$) in Chile in 2008 to that in 2010?
Offer a very short reply. 1.02. What is the ratio of the Imports (BoP, current US$) of Lebanon in 2008 to that in 2010?
Your response must be concise. 0.96. What is the ratio of the Imports (BoP, current US$) in Macedonia in 2008 to that in 2010?
Provide a short and direct response. 1.25. What is the ratio of the Imports (BoP, current US$) in Bosnia and Herzegovina in 2008 to that in 2011?
Ensure brevity in your answer.  1.09. What is the ratio of the Imports (BoP, current US$) in Chile in 2008 to that in 2011?
Your answer should be very brief. 0.8. What is the ratio of the Imports (BoP, current US$) of Lebanon in 2008 to that in 2011?
Your answer should be compact. 0.9. What is the ratio of the Imports (BoP, current US$) of Macedonia in 2008 to that in 2011?
Keep it short and to the point. 0.98. What is the ratio of the Imports (BoP, current US$) of Bosnia and Herzegovina in 2008 to that in 2012?
Ensure brevity in your answer.  1.19. What is the ratio of the Imports (BoP, current US$) in Chile in 2008 to that in 2012?
Keep it short and to the point. 0.77. What is the ratio of the Imports (BoP, current US$) in Lebanon in 2008 to that in 2012?
Your answer should be compact. 0.91. What is the ratio of the Imports (BoP, current US$) of Macedonia in 2008 to that in 2012?
Offer a very short reply. 1.05. What is the ratio of the Imports (BoP, current US$) in Bosnia and Herzegovina in 2008 to that in 2013?
Provide a succinct answer. 1.16. What is the ratio of the Imports (BoP, current US$) in Chile in 2008 to that in 2013?
Your response must be concise. 0.77. What is the ratio of the Imports (BoP, current US$) in Lebanon in 2008 to that in 2013?
Provide a short and direct response. 0.89. What is the ratio of the Imports (BoP, current US$) in Macedonia in 2008 to that in 2013?
Make the answer very short. 1.02. What is the ratio of the Imports (BoP, current US$) of Bosnia and Herzegovina in 2009 to that in 2010?
Ensure brevity in your answer.  0.98. What is the ratio of the Imports (BoP, current US$) in Chile in 2009 to that in 2010?
Your answer should be very brief. 0.74. What is the ratio of the Imports (BoP, current US$) in Lebanon in 2009 to that in 2010?
Your answer should be very brief. 0.97. What is the ratio of the Imports (BoP, current US$) of Macedonia in 2009 to that in 2010?
Ensure brevity in your answer.  0.94. What is the ratio of the Imports (BoP, current US$) of Bosnia and Herzegovina in 2009 to that in 2011?
Provide a short and direct response. 0.83. What is the ratio of the Imports (BoP, current US$) in Chile in 2009 to that in 2011?
Your response must be concise. 0.58. What is the ratio of the Imports (BoP, current US$) of Lebanon in 2009 to that in 2011?
Provide a short and direct response. 0.91. What is the ratio of the Imports (BoP, current US$) of Macedonia in 2009 to that in 2011?
Provide a short and direct response. 0.74. What is the ratio of the Imports (BoP, current US$) in Bosnia and Herzegovina in 2009 to that in 2012?
Offer a very short reply. 0.9. What is the ratio of the Imports (BoP, current US$) of Chile in 2009 to that in 2012?
Provide a succinct answer. 0.56. What is the ratio of the Imports (BoP, current US$) of Lebanon in 2009 to that in 2012?
Ensure brevity in your answer.  0.93. What is the ratio of the Imports (BoP, current US$) of Macedonia in 2009 to that in 2012?
Your response must be concise. 0.79. What is the ratio of the Imports (BoP, current US$) in Bosnia and Herzegovina in 2009 to that in 2013?
Make the answer very short. 0.88. What is the ratio of the Imports (BoP, current US$) of Chile in 2009 to that in 2013?
Provide a succinct answer. 0.56. What is the ratio of the Imports (BoP, current US$) of Lebanon in 2009 to that in 2013?
Your answer should be compact. 0.9. What is the ratio of the Imports (BoP, current US$) in Macedonia in 2009 to that in 2013?
Offer a very short reply. 0.77. What is the ratio of the Imports (BoP, current US$) of Bosnia and Herzegovina in 2010 to that in 2011?
Ensure brevity in your answer.  0.84. What is the ratio of the Imports (BoP, current US$) of Chile in 2010 to that in 2011?
Ensure brevity in your answer.  0.79. What is the ratio of the Imports (BoP, current US$) in Lebanon in 2010 to that in 2011?
Provide a succinct answer. 0.94. What is the ratio of the Imports (BoP, current US$) in Macedonia in 2010 to that in 2011?
Keep it short and to the point. 0.79. What is the ratio of the Imports (BoP, current US$) in Bosnia and Herzegovina in 2010 to that in 2012?
Keep it short and to the point. 0.92. What is the ratio of the Imports (BoP, current US$) in Chile in 2010 to that in 2012?
Offer a very short reply. 0.76. What is the ratio of the Imports (BoP, current US$) in Lebanon in 2010 to that in 2012?
Ensure brevity in your answer.  0.95. What is the ratio of the Imports (BoP, current US$) of Macedonia in 2010 to that in 2012?
Ensure brevity in your answer.  0.84. What is the ratio of the Imports (BoP, current US$) in Bosnia and Herzegovina in 2010 to that in 2013?
Keep it short and to the point. 0.89. What is the ratio of the Imports (BoP, current US$) of Chile in 2010 to that in 2013?
Offer a terse response. 0.76. What is the ratio of the Imports (BoP, current US$) in Lebanon in 2010 to that in 2013?
Ensure brevity in your answer.  0.92. What is the ratio of the Imports (BoP, current US$) of Macedonia in 2010 to that in 2013?
Your answer should be very brief. 0.82. What is the ratio of the Imports (BoP, current US$) of Bosnia and Herzegovina in 2011 to that in 2012?
Your response must be concise. 1.08. What is the ratio of the Imports (BoP, current US$) in Chile in 2011 to that in 2012?
Offer a terse response. 0.96. What is the ratio of the Imports (BoP, current US$) of Lebanon in 2011 to that in 2012?
Your response must be concise. 1.02. What is the ratio of the Imports (BoP, current US$) of Macedonia in 2011 to that in 2012?
Provide a succinct answer. 1.06. What is the ratio of the Imports (BoP, current US$) of Bosnia and Herzegovina in 2011 to that in 2013?
Your answer should be compact. 1.06. What is the ratio of the Imports (BoP, current US$) of Chile in 2011 to that in 2013?
Your answer should be compact. 0.96. What is the ratio of the Imports (BoP, current US$) of Lebanon in 2011 to that in 2013?
Your answer should be very brief. 0.99. What is the ratio of the Imports (BoP, current US$) of Macedonia in 2011 to that in 2013?
Provide a succinct answer. 1.04. What is the ratio of the Imports (BoP, current US$) in Chile in 2012 to that in 2013?
Your answer should be compact. 1. What is the ratio of the Imports (BoP, current US$) of Lebanon in 2012 to that in 2013?
Offer a terse response. 0.97. What is the ratio of the Imports (BoP, current US$) in Macedonia in 2012 to that in 2013?
Provide a short and direct response. 0.98. What is the difference between the highest and the second highest Imports (BoP, current US$) of Bosnia and Herzegovina?
Your response must be concise. 9.82e+08. What is the difference between the highest and the second highest Imports (BoP, current US$) of Chile?
Provide a succinct answer. 7.72e+07. What is the difference between the highest and the second highest Imports (BoP, current US$) of Lebanon?
Keep it short and to the point. 4.26e+08. What is the difference between the highest and the second highest Imports (BoP, current US$) of Macedonia?
Your answer should be compact. 1.15e+08. What is the difference between the highest and the lowest Imports (BoP, current US$) in Bosnia and Herzegovina?
Give a very brief answer. 2.77e+09. What is the difference between the highest and the lowest Imports (BoP, current US$) of Chile?
Give a very brief answer. 4.00e+1. What is the difference between the highest and the lowest Imports (BoP, current US$) of Lebanon?
Make the answer very short. 1.12e+1. What is the difference between the highest and the lowest Imports (BoP, current US$) in Macedonia?
Provide a succinct answer. 1.80e+09. 